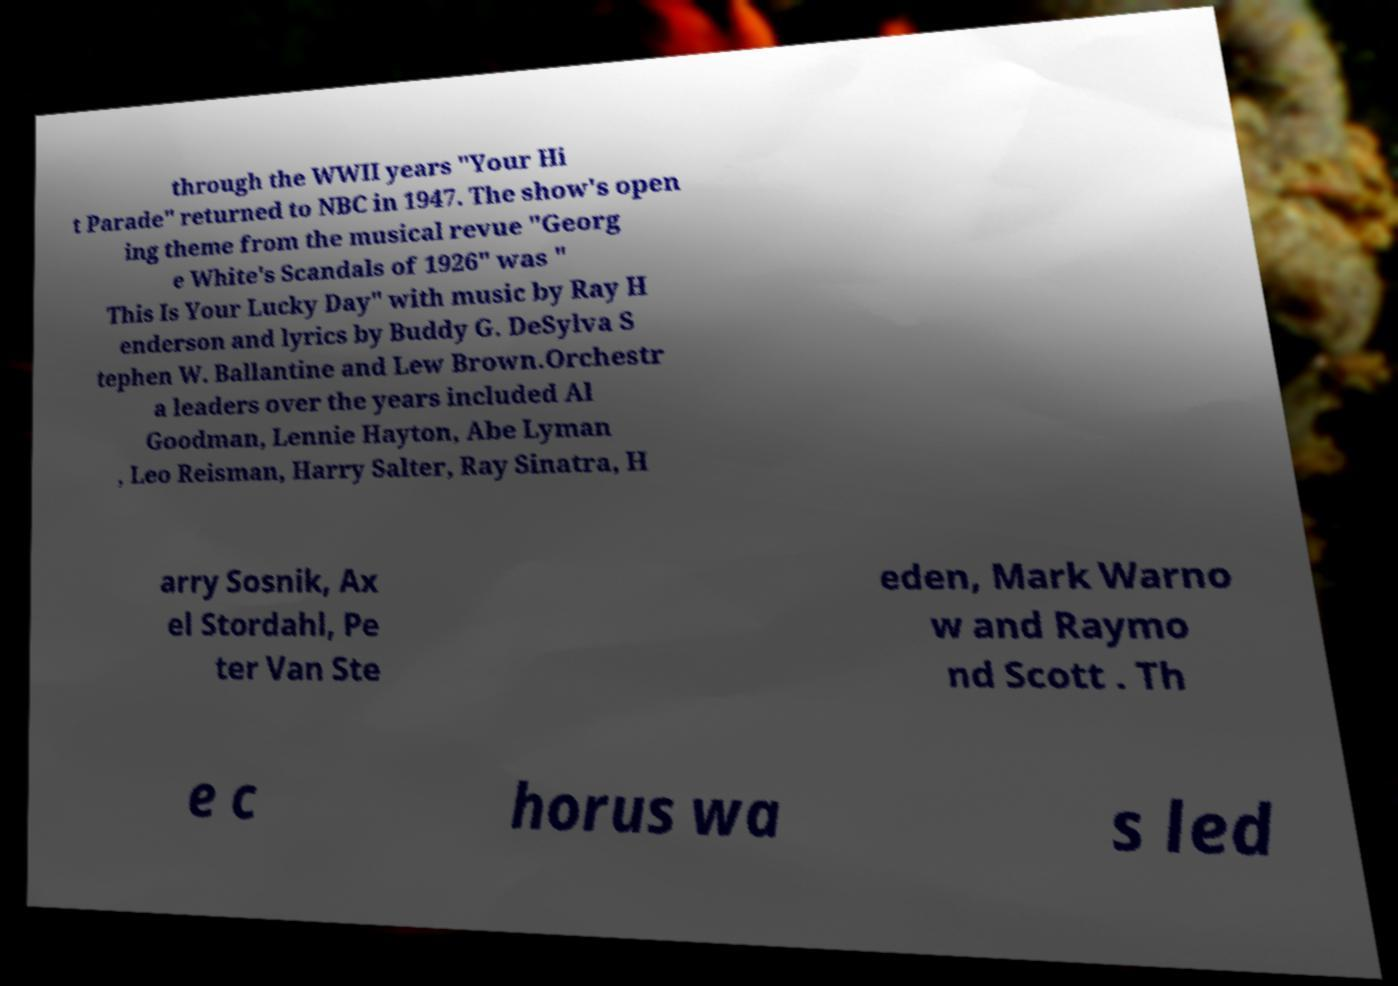Can you accurately transcribe the text from the provided image for me? through the WWII years "Your Hi t Parade" returned to NBC in 1947. The show's open ing theme from the musical revue "Georg e White's Scandals of 1926" was " This Is Your Lucky Day" with music by Ray H enderson and lyrics by Buddy G. DeSylva S tephen W. Ballantine and Lew Brown.Orchestr a leaders over the years included Al Goodman, Lennie Hayton, Abe Lyman , Leo Reisman, Harry Salter, Ray Sinatra, H arry Sosnik, Ax el Stordahl, Pe ter Van Ste eden, Mark Warno w and Raymo nd Scott . Th e c horus wa s led 